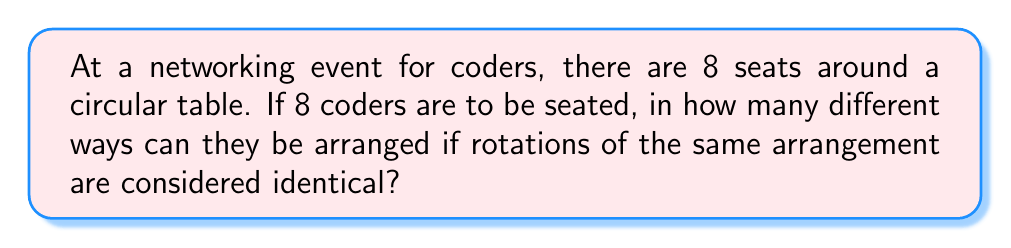Give your solution to this math problem. Let's approach this step-by-step:

1) First, we need to recognize that this is a circular permutation problem. In a circular arrangement, rotations of the same arrangement are considered identical.

2) For a linear arrangement of n distinct objects, we would have n! permutations.

3) However, in a circular arrangement, we can fix one person's position and arrange the rest. This is because rotating everyone one position to the left or right would result in an arrangement that's considered identical.

4) So, we can think of this as arranging (n-1) people in a line, with the nth person's position fixed.

5) In this case, we have 8 coders, so we're arranging 7 coders in a line.

6) The number of ways to arrange 7 people in a line is simply 7!

Therefore, the number of unique circular arrangements is:

$$ (8-1)! = 7! = 7 \times 6 \times 5 \times 4 \times 3 \times 2 \times 1 = 5040 $$

This means there are 5040 different ways to seat the 8 coders around the circular table.
Answer: 5040 